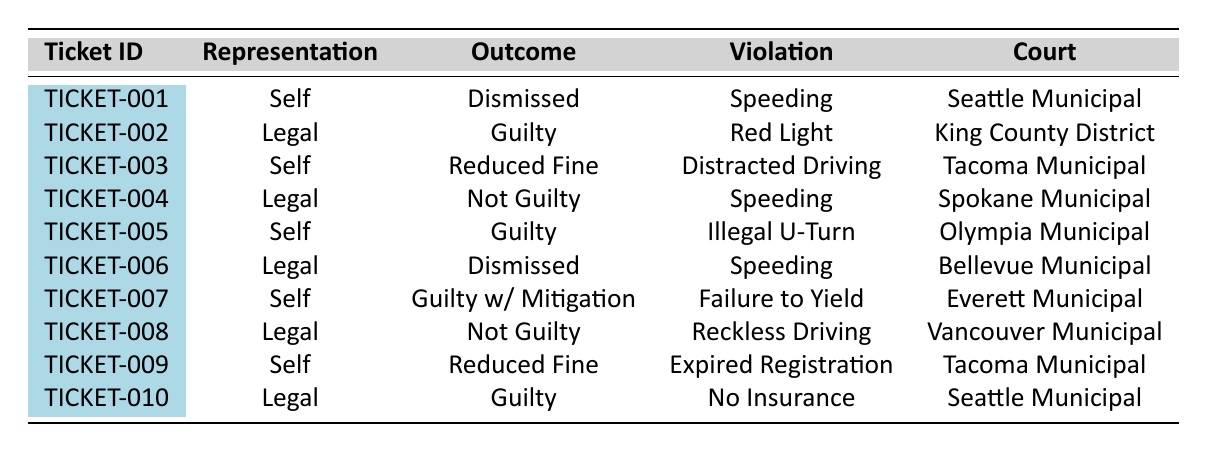What is the outcome of ticket TICKET-001? The table indicates that for ticket TICKET-001, the outcome is listed as "Dismissed."
Answer: Dismissed How many tickets were contested using self-representation? By counting the entries under the "Representation" column for "Self," there are 5 tickets listed: TICKET-001, TICKET-003, TICKET-005, TICKET-007, and TICKET-009.
Answer: 5 What is the violation type for the ticket that was "Not Guilty"? The entries indicate two "Not Guilty" outcomes: TICKET-004 and TICKET-008. For TICKET-004, the violation type is "Speeding," and for TICKET-008, it's "Reckless Driving."
Answer: Speeding, Reckless Driving What was the outcome of the contest for the violation "Driving Without Insurance"? The table shows that for the violation "Driving Without Insurance," the outcome was "Guilty" for ticket TICKET-010.
Answer: Guilty Which court had the highest number of self-representation tickets? Analyzing the table, both Tacoma Municipal Court and Olympia Municipal Court had self-representation tickets (TICKET-003, TICKET-009, and TICKET-005). Both had 2 tickets, but Tacoma Municipal Court has an additional reduction. Therefore, it ties for the highest count.
Answer: Tacoma Municipal Court and Olympia Municipal Court What percentage of tickets resulted in a "Dismissed" outcome? The total number of tickets is 10. There are 3 tickets with "Dismissed" outcomes (TICKET-001 and TICKET-006). The percentage is calculated as (3/10) * 100 = 30%.
Answer: 30% Is there any ticket with a "Guilty" outcome that was contested by self-representation? Looking at the table, TICKET-005 and TICKET-007 show "Guilty" outcomes for self-representation, making the statement true.
Answer: Yes What is the difference in outcomes between tickets contested by self-representation and legal representation? The outcomes for self-representation involved "Dismissed," "Reduced Fine," "Guilty," and "Guilty with Mitigation." For legal representation, the outcomes were "Guilty," "Not Guilty," and "Dismissed." Comparing them reveals variations in the outcomes, with legal representation offering more "Not Guilty" outcomes.
Answer: Legal representation has more favorable outcomes in terms of "Not Guilty." Which judge presided over the ticket with the "Reduced Fine" outcome? The table shows that TICKET-003 resulted in a "Reduced Fine," overseen by Judge Susan Lee.
Answer: Judge Susan Lee What is the ratio of "Guilty" outcomes to "Not Guilty" outcomes for tickets contested by legal representation? There are 3 "Guilty" outcomes (TICKET-002, TICKET-010) and 2 "Not Guilty" outcomes (TICKET-004, TICKET-008) for legal representation. The ratio is 3:2.
Answer: 3:2 Which type of violation had the most favorable outcome for self-representation? The outcomes for self-representation included "Dismissed," "Reduced Fine," and "Guilty with Mitigation," with "Dismissed" being the most favorable outcome. TICKET-001 was for "Speeding."
Answer: Speeding 